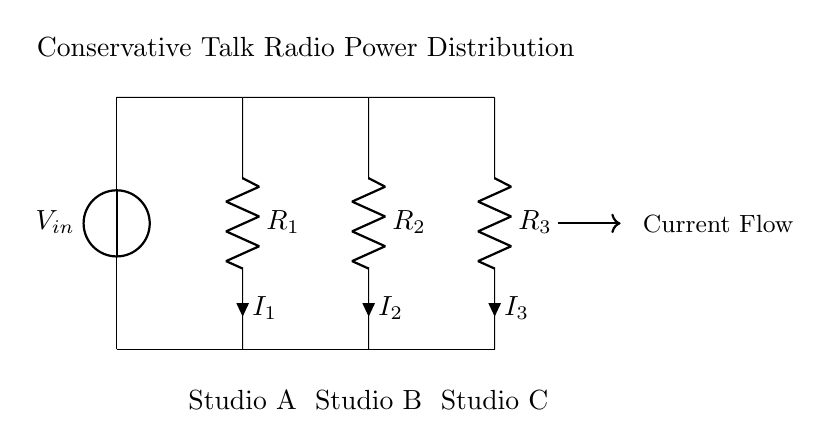What is the input voltage of the circuit? The input voltage is labeled as V_in at the top of the circuit diagram, indicating the voltage provided to the circuit.
Answer: V_in How many resistors are present in the circuit? The circuit includes three resistors (R1, R2, and R3), each positioned in parallel, as shown in the diagram.
Answer: 3 Which studio has the resistor with the label R2? Studio B is labeled in the diagram and is associated with the resistor R2, indicating its position in the circuit.
Answer: Studio B What is the current flowing through resistor R1? The current flowing through resistor R1 is labeled as I1 in the circuit diagram, which specifies its value based on the current divider rule.
Answer: I1 If R1 has a value of 2 ohms and R2 has a value of 3 ohms, what is the relationship of currents in R1 and R2? The relationship can be determined applying the current divider rule, which states the current through each resistor is inversely proportional to its resistance. Therefore, since R1 has a lower resistance, it will carry a higher current compared to R2.
Answer: I1 > I2 In what configuration are the resistors connected in this circuit? The resistors are connected in parallel, as they share the same input voltage and are arranged side by side, distributing current accordingly.
Answer: Parallel 